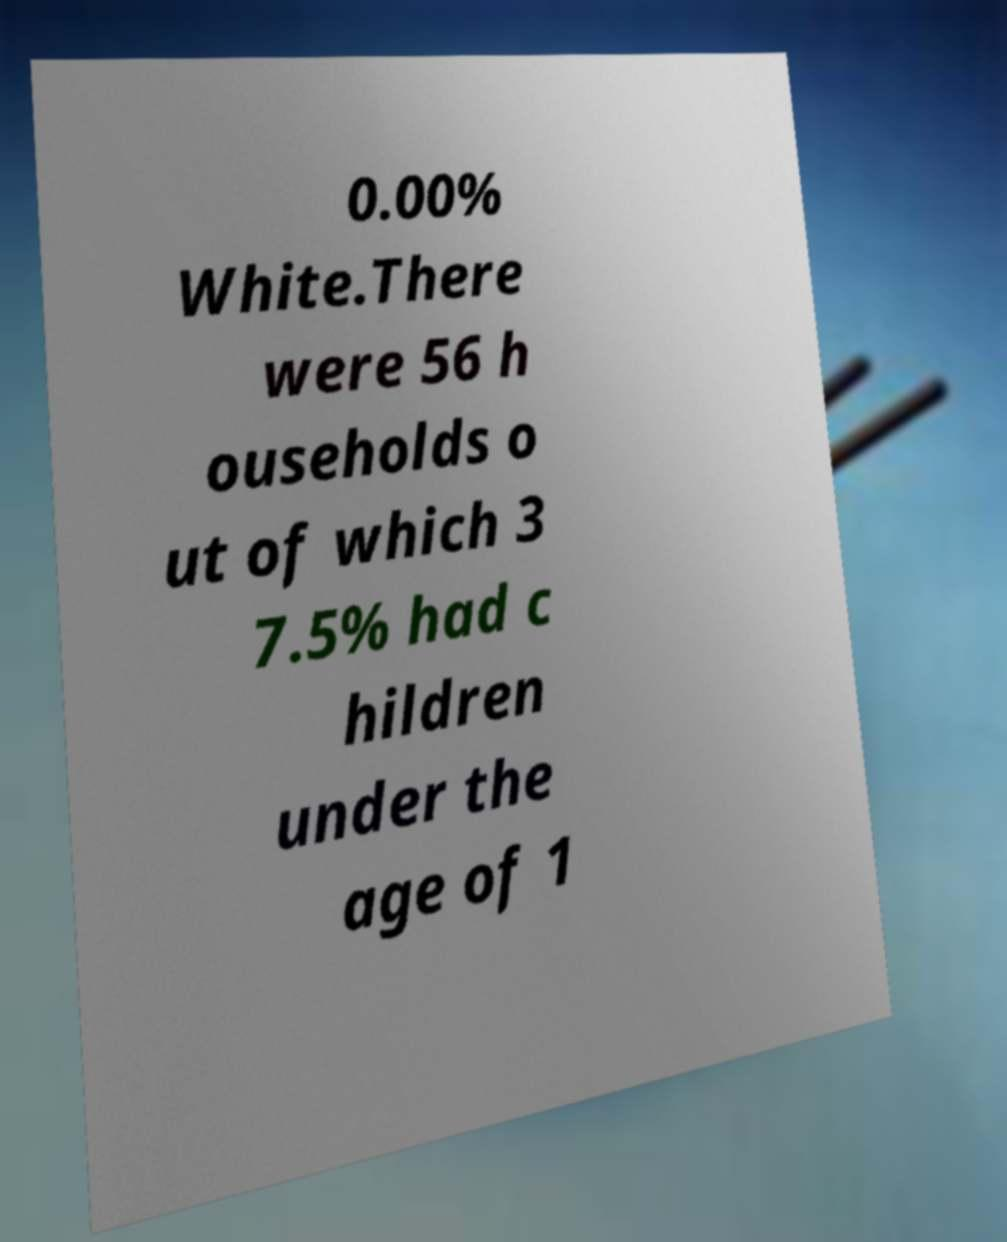Could you extract and type out the text from this image? 0.00% White.There were 56 h ouseholds o ut of which 3 7.5% had c hildren under the age of 1 